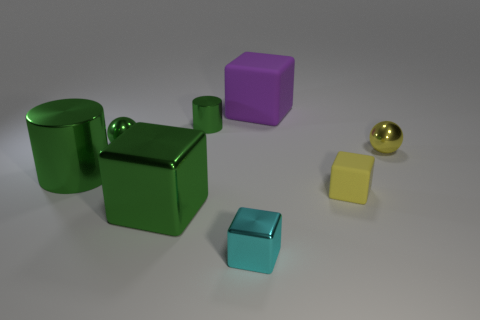Add 1 tiny green metal cylinders. How many objects exist? 9 Subtract all green cubes. How many cubes are left? 3 Subtract 0 cyan cylinders. How many objects are left? 8 Subtract all cylinders. How many objects are left? 6 Subtract 2 cylinders. How many cylinders are left? 0 Subtract all purple balls. Subtract all red cylinders. How many balls are left? 2 Subtract all purple blocks. How many brown spheres are left? 0 Subtract all tiny green metallic spheres. Subtract all green metallic objects. How many objects are left? 3 Add 1 small yellow shiny spheres. How many small yellow shiny spheres are left? 2 Add 4 yellow shiny objects. How many yellow shiny objects exist? 5 